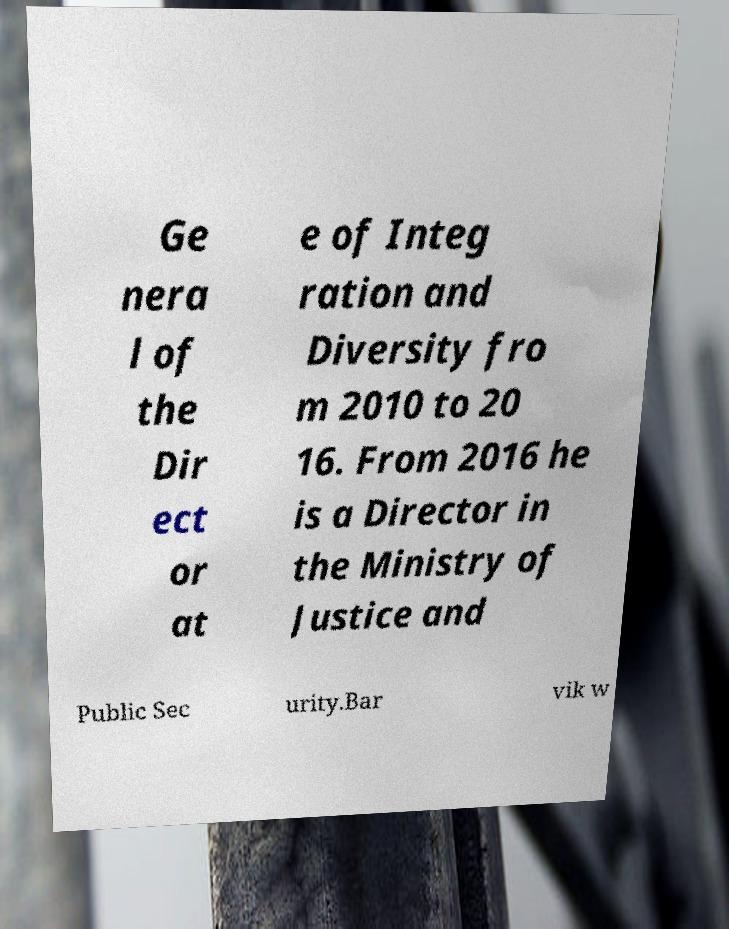What messages or text are displayed in this image? I need them in a readable, typed format. Ge nera l of the Dir ect or at e of Integ ration and Diversity fro m 2010 to 20 16. From 2016 he is a Director in the Ministry of Justice and Public Sec urity.Bar vik w 